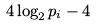<formula> <loc_0><loc_0><loc_500><loc_500>4 \log _ { 2 } p _ { i } - 4</formula> 